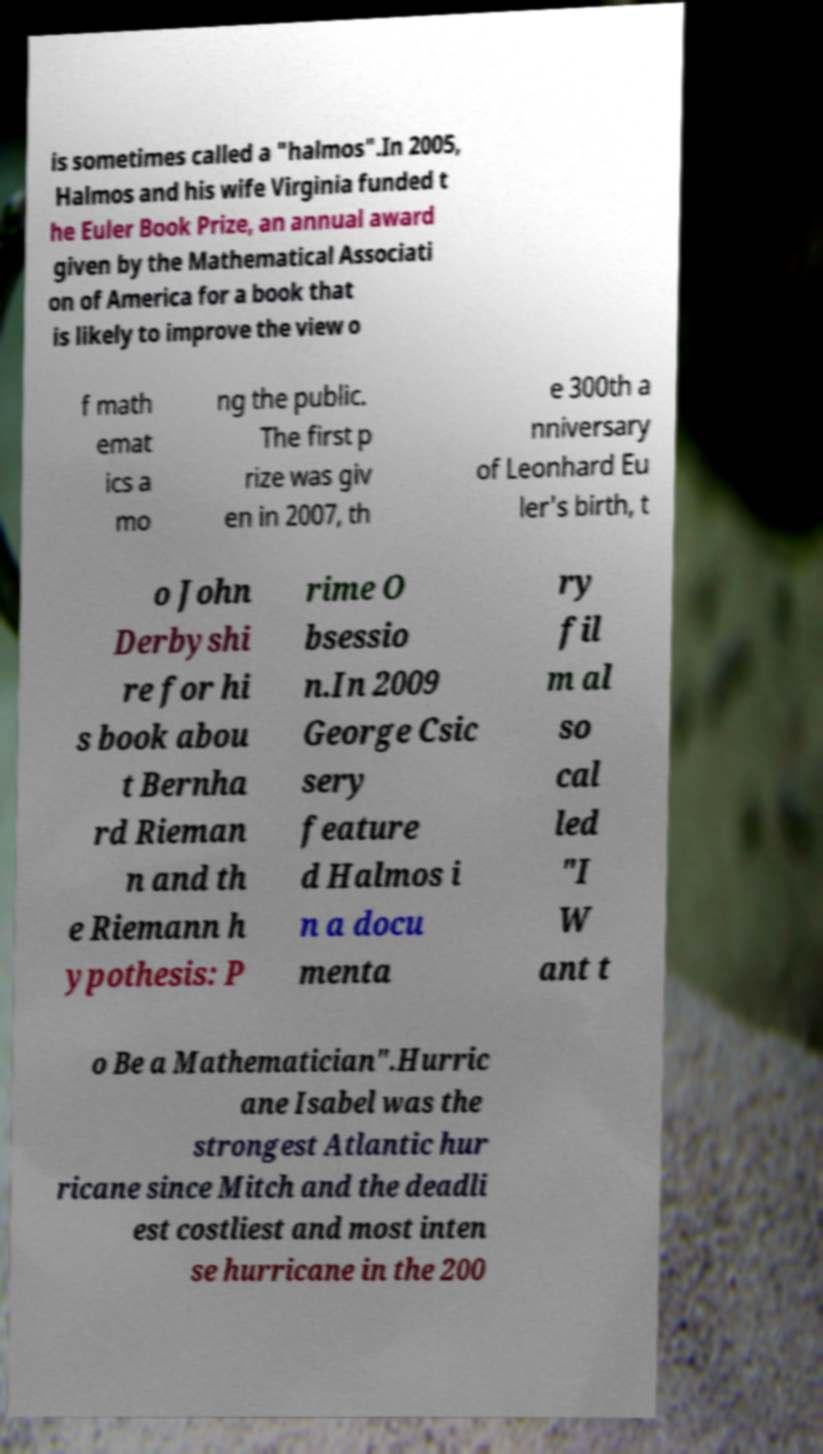Please read and relay the text visible in this image. What does it say? is sometimes called a "halmos".In 2005, Halmos and his wife Virginia funded t he Euler Book Prize, an annual award given by the Mathematical Associati on of America for a book that is likely to improve the view o f math emat ics a mo ng the public. The first p rize was giv en in 2007, th e 300th a nniversary of Leonhard Eu ler's birth, t o John Derbyshi re for hi s book abou t Bernha rd Rieman n and th e Riemann h ypothesis: P rime O bsessio n.In 2009 George Csic sery feature d Halmos i n a docu menta ry fil m al so cal led "I W ant t o Be a Mathematician".Hurric ane Isabel was the strongest Atlantic hur ricane since Mitch and the deadli est costliest and most inten se hurricane in the 200 